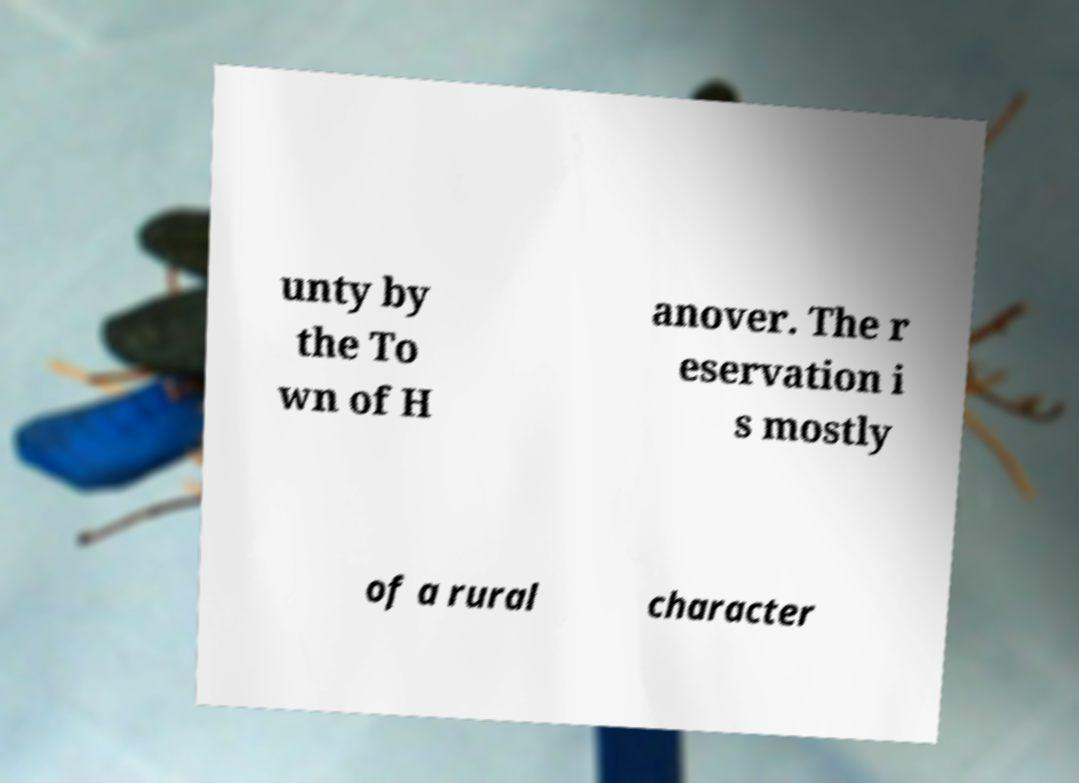I need the written content from this picture converted into text. Can you do that? unty by the To wn of H anover. The r eservation i s mostly of a rural character 